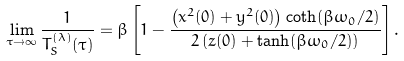Convert formula to latex. <formula><loc_0><loc_0><loc_500><loc_500>\lim _ { \tau \to \infty } \frac { 1 } { T ^ { ( \lambda ) } _ { S } ( \tau ) } = \beta \left [ 1 - \frac { \left ( x ^ { 2 } ( 0 ) + y ^ { 2 } ( 0 ) \right ) \coth ( \beta \omega _ { 0 } / 2 ) } { 2 \left ( z ( 0 ) + \tanh ( \beta \omega _ { 0 } / 2 ) \right ) } \right ] .</formula> 